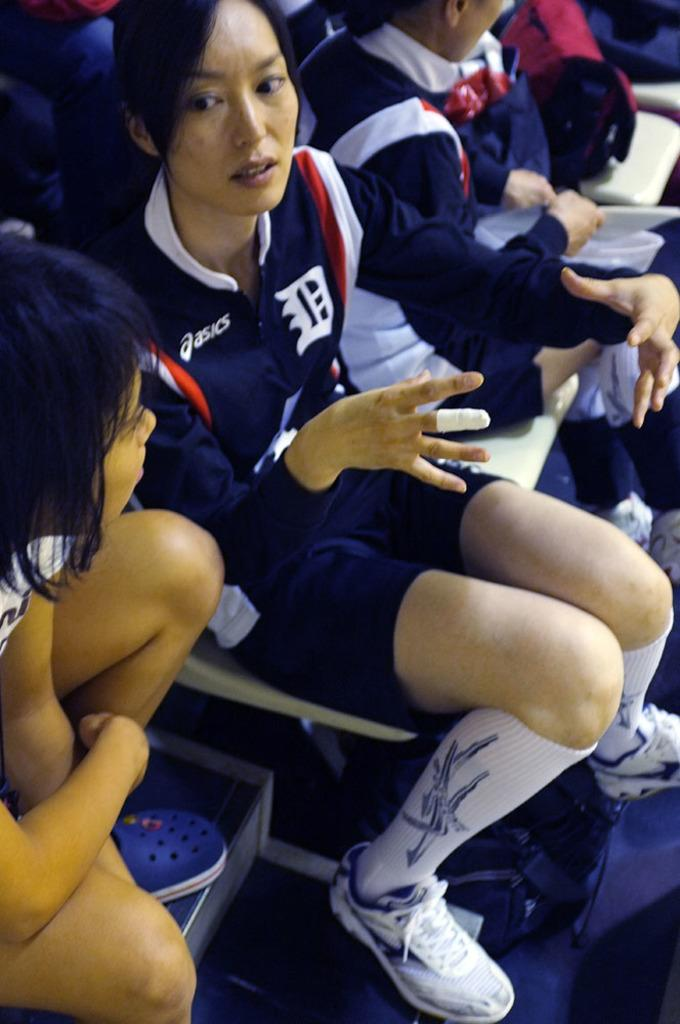<image>
Describe the image concisely. A young adult Asian woman in a sports team uniform sits on a chair among other seated young women. 